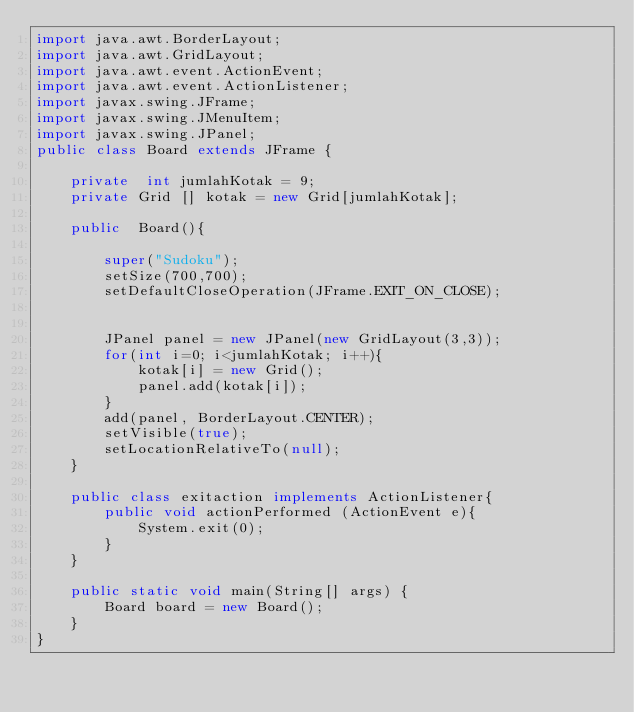<code> <loc_0><loc_0><loc_500><loc_500><_Java_>import java.awt.BorderLayout;
import java.awt.GridLayout;
import java.awt.event.ActionEvent;
import java.awt.event.ActionListener;
import javax.swing.JFrame;
import javax.swing.JMenuItem;
import javax.swing.JPanel;
public class Board extends JFrame {

    private  int jumlahKotak = 9;
    private Grid [] kotak = new Grid[jumlahKotak];

    public  Board(){

        super("Sudoku");
        setSize(700,700);
        setDefaultCloseOperation(JFrame.EXIT_ON_CLOSE);


        JPanel panel = new JPanel(new GridLayout(3,3));
        for(int i=0; i<jumlahKotak; i++){
            kotak[i] = new Grid();
            panel.add(kotak[i]);
        }
        add(panel, BorderLayout.CENTER);
        setVisible(true);
        setLocationRelativeTo(null);
    }

    public class exitaction implements ActionListener{
        public void actionPerformed (ActionEvent e){
            System.exit(0);
        }
    }

    public static void main(String[] args) { 
        Board board = new Board();
    }    
}</code> 